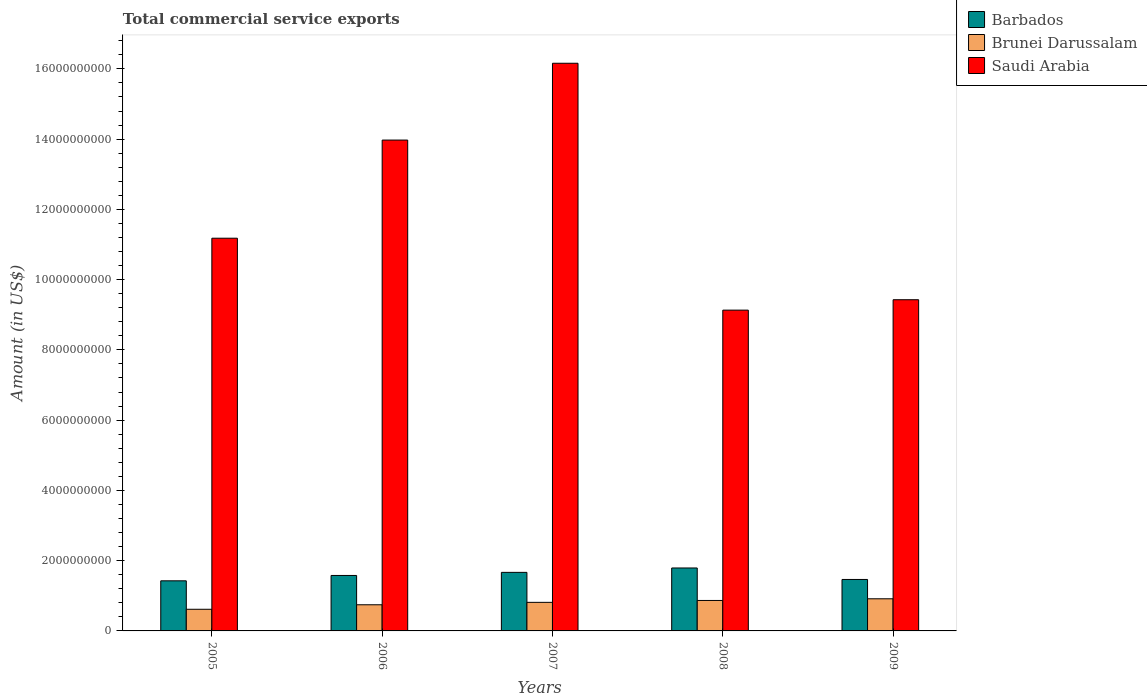How many different coloured bars are there?
Offer a terse response. 3. Are the number of bars per tick equal to the number of legend labels?
Give a very brief answer. Yes. How many bars are there on the 1st tick from the left?
Make the answer very short. 3. How many bars are there on the 2nd tick from the right?
Your answer should be compact. 3. What is the total commercial service exports in Saudi Arabia in 2006?
Ensure brevity in your answer.  1.40e+1. Across all years, what is the maximum total commercial service exports in Saudi Arabia?
Provide a short and direct response. 1.62e+1. Across all years, what is the minimum total commercial service exports in Barbados?
Offer a terse response. 1.43e+09. In which year was the total commercial service exports in Brunei Darussalam minimum?
Provide a succinct answer. 2005. What is the total total commercial service exports in Brunei Darussalam in the graph?
Provide a succinct answer. 3.96e+09. What is the difference between the total commercial service exports in Saudi Arabia in 2005 and that in 2008?
Ensure brevity in your answer.  2.05e+09. What is the difference between the total commercial service exports in Brunei Darussalam in 2007 and the total commercial service exports in Saudi Arabia in 2005?
Your answer should be compact. -1.04e+1. What is the average total commercial service exports in Barbados per year?
Ensure brevity in your answer.  1.59e+09. In the year 2008, what is the difference between the total commercial service exports in Brunei Darussalam and total commercial service exports in Barbados?
Provide a succinct answer. -9.25e+08. In how many years, is the total commercial service exports in Barbados greater than 800000000 US$?
Provide a succinct answer. 5. What is the ratio of the total commercial service exports in Brunei Darussalam in 2006 to that in 2009?
Your answer should be very brief. 0.81. Is the total commercial service exports in Barbados in 2006 less than that in 2008?
Make the answer very short. Yes. Is the difference between the total commercial service exports in Brunei Darussalam in 2005 and 2009 greater than the difference between the total commercial service exports in Barbados in 2005 and 2009?
Offer a terse response. No. What is the difference between the highest and the second highest total commercial service exports in Brunei Darussalam?
Give a very brief answer. 4.77e+07. What is the difference between the highest and the lowest total commercial service exports in Saudi Arabia?
Offer a terse response. 7.03e+09. In how many years, is the total commercial service exports in Saudi Arabia greater than the average total commercial service exports in Saudi Arabia taken over all years?
Provide a short and direct response. 2. What does the 2nd bar from the left in 2006 represents?
Give a very brief answer. Brunei Darussalam. What does the 2nd bar from the right in 2008 represents?
Offer a very short reply. Brunei Darussalam. Is it the case that in every year, the sum of the total commercial service exports in Barbados and total commercial service exports in Saudi Arabia is greater than the total commercial service exports in Brunei Darussalam?
Make the answer very short. Yes. Are all the bars in the graph horizontal?
Your response must be concise. No. What is the difference between two consecutive major ticks on the Y-axis?
Your answer should be compact. 2.00e+09. Does the graph contain any zero values?
Offer a very short reply. No. Where does the legend appear in the graph?
Your answer should be very brief. Top right. What is the title of the graph?
Offer a terse response. Total commercial service exports. Does "Egypt, Arab Rep." appear as one of the legend labels in the graph?
Provide a succinct answer. No. What is the label or title of the X-axis?
Ensure brevity in your answer.  Years. What is the Amount (in US$) of Barbados in 2005?
Make the answer very short. 1.43e+09. What is the Amount (in US$) in Brunei Darussalam in 2005?
Ensure brevity in your answer.  6.16e+08. What is the Amount (in US$) in Saudi Arabia in 2005?
Provide a short and direct response. 1.12e+1. What is the Amount (in US$) of Barbados in 2006?
Offer a terse response. 1.58e+09. What is the Amount (in US$) of Brunei Darussalam in 2006?
Provide a short and direct response. 7.45e+08. What is the Amount (in US$) in Saudi Arabia in 2006?
Provide a succinct answer. 1.40e+1. What is the Amount (in US$) of Barbados in 2007?
Your response must be concise. 1.67e+09. What is the Amount (in US$) of Brunei Darussalam in 2007?
Offer a very short reply. 8.13e+08. What is the Amount (in US$) in Saudi Arabia in 2007?
Offer a terse response. 1.62e+1. What is the Amount (in US$) in Barbados in 2008?
Give a very brief answer. 1.79e+09. What is the Amount (in US$) of Brunei Darussalam in 2008?
Provide a short and direct response. 8.67e+08. What is the Amount (in US$) in Saudi Arabia in 2008?
Offer a terse response. 9.13e+09. What is the Amount (in US$) of Barbados in 2009?
Your response must be concise. 1.46e+09. What is the Amount (in US$) in Brunei Darussalam in 2009?
Your answer should be very brief. 9.15e+08. What is the Amount (in US$) in Saudi Arabia in 2009?
Provide a succinct answer. 9.43e+09. Across all years, what is the maximum Amount (in US$) in Barbados?
Make the answer very short. 1.79e+09. Across all years, what is the maximum Amount (in US$) of Brunei Darussalam?
Provide a short and direct response. 9.15e+08. Across all years, what is the maximum Amount (in US$) in Saudi Arabia?
Provide a succinct answer. 1.62e+1. Across all years, what is the minimum Amount (in US$) of Barbados?
Give a very brief answer. 1.43e+09. Across all years, what is the minimum Amount (in US$) in Brunei Darussalam?
Your answer should be compact. 6.16e+08. Across all years, what is the minimum Amount (in US$) of Saudi Arabia?
Keep it short and to the point. 9.13e+09. What is the total Amount (in US$) in Barbados in the graph?
Ensure brevity in your answer.  7.93e+09. What is the total Amount (in US$) of Brunei Darussalam in the graph?
Your answer should be compact. 3.96e+09. What is the total Amount (in US$) of Saudi Arabia in the graph?
Make the answer very short. 5.99e+1. What is the difference between the Amount (in US$) in Barbados in 2005 and that in 2006?
Give a very brief answer. -1.53e+08. What is the difference between the Amount (in US$) in Brunei Darussalam in 2005 and that in 2006?
Offer a very short reply. -1.28e+08. What is the difference between the Amount (in US$) of Saudi Arabia in 2005 and that in 2006?
Make the answer very short. -2.79e+09. What is the difference between the Amount (in US$) in Barbados in 2005 and that in 2007?
Offer a terse response. -2.41e+08. What is the difference between the Amount (in US$) in Brunei Darussalam in 2005 and that in 2007?
Your answer should be very brief. -1.97e+08. What is the difference between the Amount (in US$) of Saudi Arabia in 2005 and that in 2007?
Keep it short and to the point. -4.98e+09. What is the difference between the Amount (in US$) in Barbados in 2005 and that in 2008?
Your response must be concise. -3.66e+08. What is the difference between the Amount (in US$) in Brunei Darussalam in 2005 and that in 2008?
Offer a terse response. -2.51e+08. What is the difference between the Amount (in US$) of Saudi Arabia in 2005 and that in 2008?
Keep it short and to the point. 2.05e+09. What is the difference between the Amount (in US$) in Barbados in 2005 and that in 2009?
Offer a terse response. -3.87e+07. What is the difference between the Amount (in US$) in Brunei Darussalam in 2005 and that in 2009?
Give a very brief answer. -2.99e+08. What is the difference between the Amount (in US$) in Saudi Arabia in 2005 and that in 2009?
Provide a short and direct response. 1.75e+09. What is the difference between the Amount (in US$) in Barbados in 2006 and that in 2007?
Offer a terse response. -8.84e+07. What is the difference between the Amount (in US$) of Brunei Darussalam in 2006 and that in 2007?
Give a very brief answer. -6.88e+07. What is the difference between the Amount (in US$) of Saudi Arabia in 2006 and that in 2007?
Your response must be concise. -2.19e+09. What is the difference between the Amount (in US$) in Barbados in 2006 and that in 2008?
Keep it short and to the point. -2.13e+08. What is the difference between the Amount (in US$) of Brunei Darussalam in 2006 and that in 2008?
Make the answer very short. -1.23e+08. What is the difference between the Amount (in US$) in Saudi Arabia in 2006 and that in 2008?
Keep it short and to the point. 4.84e+09. What is the difference between the Amount (in US$) in Barbados in 2006 and that in 2009?
Make the answer very short. 1.14e+08. What is the difference between the Amount (in US$) in Brunei Darussalam in 2006 and that in 2009?
Your answer should be very brief. -1.70e+08. What is the difference between the Amount (in US$) of Saudi Arabia in 2006 and that in 2009?
Your answer should be compact. 4.55e+09. What is the difference between the Amount (in US$) in Barbados in 2007 and that in 2008?
Your response must be concise. -1.25e+08. What is the difference between the Amount (in US$) in Brunei Darussalam in 2007 and that in 2008?
Provide a succinct answer. -5.39e+07. What is the difference between the Amount (in US$) in Saudi Arabia in 2007 and that in 2008?
Ensure brevity in your answer.  7.03e+09. What is the difference between the Amount (in US$) of Barbados in 2007 and that in 2009?
Give a very brief answer. 2.02e+08. What is the difference between the Amount (in US$) of Brunei Darussalam in 2007 and that in 2009?
Make the answer very short. -1.02e+08. What is the difference between the Amount (in US$) in Saudi Arabia in 2007 and that in 2009?
Keep it short and to the point. 6.73e+09. What is the difference between the Amount (in US$) in Barbados in 2008 and that in 2009?
Give a very brief answer. 3.27e+08. What is the difference between the Amount (in US$) of Brunei Darussalam in 2008 and that in 2009?
Provide a short and direct response. -4.77e+07. What is the difference between the Amount (in US$) in Saudi Arabia in 2008 and that in 2009?
Make the answer very short. -2.96e+08. What is the difference between the Amount (in US$) in Barbados in 2005 and the Amount (in US$) in Brunei Darussalam in 2006?
Make the answer very short. 6.82e+08. What is the difference between the Amount (in US$) of Barbados in 2005 and the Amount (in US$) of Saudi Arabia in 2006?
Offer a very short reply. -1.25e+1. What is the difference between the Amount (in US$) of Brunei Darussalam in 2005 and the Amount (in US$) of Saudi Arabia in 2006?
Ensure brevity in your answer.  -1.34e+1. What is the difference between the Amount (in US$) in Barbados in 2005 and the Amount (in US$) in Brunei Darussalam in 2007?
Your answer should be compact. 6.13e+08. What is the difference between the Amount (in US$) in Barbados in 2005 and the Amount (in US$) in Saudi Arabia in 2007?
Offer a very short reply. -1.47e+1. What is the difference between the Amount (in US$) of Brunei Darussalam in 2005 and the Amount (in US$) of Saudi Arabia in 2007?
Offer a terse response. -1.55e+1. What is the difference between the Amount (in US$) of Barbados in 2005 and the Amount (in US$) of Brunei Darussalam in 2008?
Give a very brief answer. 5.59e+08. What is the difference between the Amount (in US$) of Barbados in 2005 and the Amount (in US$) of Saudi Arabia in 2008?
Your response must be concise. -7.71e+09. What is the difference between the Amount (in US$) in Brunei Darussalam in 2005 and the Amount (in US$) in Saudi Arabia in 2008?
Your answer should be compact. -8.52e+09. What is the difference between the Amount (in US$) of Barbados in 2005 and the Amount (in US$) of Brunei Darussalam in 2009?
Your response must be concise. 5.11e+08. What is the difference between the Amount (in US$) in Barbados in 2005 and the Amount (in US$) in Saudi Arabia in 2009?
Provide a short and direct response. -8.00e+09. What is the difference between the Amount (in US$) in Brunei Darussalam in 2005 and the Amount (in US$) in Saudi Arabia in 2009?
Your answer should be compact. -8.81e+09. What is the difference between the Amount (in US$) of Barbados in 2006 and the Amount (in US$) of Brunei Darussalam in 2007?
Offer a very short reply. 7.65e+08. What is the difference between the Amount (in US$) in Barbados in 2006 and the Amount (in US$) in Saudi Arabia in 2007?
Your answer should be very brief. -1.46e+1. What is the difference between the Amount (in US$) in Brunei Darussalam in 2006 and the Amount (in US$) in Saudi Arabia in 2007?
Your answer should be very brief. -1.54e+1. What is the difference between the Amount (in US$) of Barbados in 2006 and the Amount (in US$) of Brunei Darussalam in 2008?
Offer a very short reply. 7.11e+08. What is the difference between the Amount (in US$) in Barbados in 2006 and the Amount (in US$) in Saudi Arabia in 2008?
Ensure brevity in your answer.  -7.55e+09. What is the difference between the Amount (in US$) in Brunei Darussalam in 2006 and the Amount (in US$) in Saudi Arabia in 2008?
Keep it short and to the point. -8.39e+09. What is the difference between the Amount (in US$) of Barbados in 2006 and the Amount (in US$) of Brunei Darussalam in 2009?
Provide a succinct answer. 6.64e+08. What is the difference between the Amount (in US$) of Barbados in 2006 and the Amount (in US$) of Saudi Arabia in 2009?
Offer a very short reply. -7.85e+09. What is the difference between the Amount (in US$) of Brunei Darussalam in 2006 and the Amount (in US$) of Saudi Arabia in 2009?
Your answer should be very brief. -8.68e+09. What is the difference between the Amount (in US$) in Barbados in 2007 and the Amount (in US$) in Brunei Darussalam in 2008?
Offer a terse response. 8.00e+08. What is the difference between the Amount (in US$) of Barbados in 2007 and the Amount (in US$) of Saudi Arabia in 2008?
Offer a very short reply. -7.46e+09. What is the difference between the Amount (in US$) in Brunei Darussalam in 2007 and the Amount (in US$) in Saudi Arabia in 2008?
Your answer should be very brief. -8.32e+09. What is the difference between the Amount (in US$) of Barbados in 2007 and the Amount (in US$) of Brunei Darussalam in 2009?
Provide a short and direct response. 7.52e+08. What is the difference between the Amount (in US$) in Barbados in 2007 and the Amount (in US$) in Saudi Arabia in 2009?
Give a very brief answer. -7.76e+09. What is the difference between the Amount (in US$) in Brunei Darussalam in 2007 and the Amount (in US$) in Saudi Arabia in 2009?
Make the answer very short. -8.61e+09. What is the difference between the Amount (in US$) of Barbados in 2008 and the Amount (in US$) of Brunei Darussalam in 2009?
Your answer should be very brief. 8.77e+08. What is the difference between the Amount (in US$) of Barbados in 2008 and the Amount (in US$) of Saudi Arabia in 2009?
Your answer should be very brief. -7.64e+09. What is the difference between the Amount (in US$) in Brunei Darussalam in 2008 and the Amount (in US$) in Saudi Arabia in 2009?
Make the answer very short. -8.56e+09. What is the average Amount (in US$) in Barbados per year?
Your response must be concise. 1.59e+09. What is the average Amount (in US$) of Brunei Darussalam per year?
Your response must be concise. 7.91e+08. What is the average Amount (in US$) of Saudi Arabia per year?
Keep it short and to the point. 1.20e+1. In the year 2005, what is the difference between the Amount (in US$) in Barbados and Amount (in US$) in Brunei Darussalam?
Make the answer very short. 8.10e+08. In the year 2005, what is the difference between the Amount (in US$) in Barbados and Amount (in US$) in Saudi Arabia?
Provide a succinct answer. -9.75e+09. In the year 2005, what is the difference between the Amount (in US$) in Brunei Darussalam and Amount (in US$) in Saudi Arabia?
Provide a short and direct response. -1.06e+1. In the year 2006, what is the difference between the Amount (in US$) in Barbados and Amount (in US$) in Brunei Darussalam?
Provide a succinct answer. 8.34e+08. In the year 2006, what is the difference between the Amount (in US$) in Barbados and Amount (in US$) in Saudi Arabia?
Your answer should be compact. -1.24e+1. In the year 2006, what is the difference between the Amount (in US$) in Brunei Darussalam and Amount (in US$) in Saudi Arabia?
Ensure brevity in your answer.  -1.32e+1. In the year 2007, what is the difference between the Amount (in US$) in Barbados and Amount (in US$) in Brunei Darussalam?
Ensure brevity in your answer.  8.54e+08. In the year 2007, what is the difference between the Amount (in US$) of Barbados and Amount (in US$) of Saudi Arabia?
Provide a short and direct response. -1.45e+1. In the year 2007, what is the difference between the Amount (in US$) in Brunei Darussalam and Amount (in US$) in Saudi Arabia?
Offer a very short reply. -1.53e+1. In the year 2008, what is the difference between the Amount (in US$) of Barbados and Amount (in US$) of Brunei Darussalam?
Your answer should be compact. 9.25e+08. In the year 2008, what is the difference between the Amount (in US$) in Barbados and Amount (in US$) in Saudi Arabia?
Your response must be concise. -7.34e+09. In the year 2008, what is the difference between the Amount (in US$) of Brunei Darussalam and Amount (in US$) of Saudi Arabia?
Keep it short and to the point. -8.26e+09. In the year 2009, what is the difference between the Amount (in US$) in Barbados and Amount (in US$) in Brunei Darussalam?
Your answer should be compact. 5.50e+08. In the year 2009, what is the difference between the Amount (in US$) of Barbados and Amount (in US$) of Saudi Arabia?
Ensure brevity in your answer.  -7.96e+09. In the year 2009, what is the difference between the Amount (in US$) of Brunei Darussalam and Amount (in US$) of Saudi Arabia?
Keep it short and to the point. -8.51e+09. What is the ratio of the Amount (in US$) in Barbados in 2005 to that in 2006?
Offer a terse response. 0.9. What is the ratio of the Amount (in US$) of Brunei Darussalam in 2005 to that in 2006?
Make the answer very short. 0.83. What is the ratio of the Amount (in US$) in Saudi Arabia in 2005 to that in 2006?
Your response must be concise. 0.8. What is the ratio of the Amount (in US$) in Barbados in 2005 to that in 2007?
Your response must be concise. 0.86. What is the ratio of the Amount (in US$) of Brunei Darussalam in 2005 to that in 2007?
Provide a short and direct response. 0.76. What is the ratio of the Amount (in US$) in Saudi Arabia in 2005 to that in 2007?
Your response must be concise. 0.69. What is the ratio of the Amount (in US$) in Barbados in 2005 to that in 2008?
Make the answer very short. 0.8. What is the ratio of the Amount (in US$) in Brunei Darussalam in 2005 to that in 2008?
Offer a terse response. 0.71. What is the ratio of the Amount (in US$) of Saudi Arabia in 2005 to that in 2008?
Keep it short and to the point. 1.22. What is the ratio of the Amount (in US$) of Barbados in 2005 to that in 2009?
Your response must be concise. 0.97. What is the ratio of the Amount (in US$) in Brunei Darussalam in 2005 to that in 2009?
Make the answer very short. 0.67. What is the ratio of the Amount (in US$) in Saudi Arabia in 2005 to that in 2009?
Your answer should be compact. 1.19. What is the ratio of the Amount (in US$) in Barbados in 2006 to that in 2007?
Keep it short and to the point. 0.95. What is the ratio of the Amount (in US$) in Brunei Darussalam in 2006 to that in 2007?
Ensure brevity in your answer.  0.92. What is the ratio of the Amount (in US$) of Saudi Arabia in 2006 to that in 2007?
Provide a short and direct response. 0.86. What is the ratio of the Amount (in US$) of Barbados in 2006 to that in 2008?
Ensure brevity in your answer.  0.88. What is the ratio of the Amount (in US$) in Brunei Darussalam in 2006 to that in 2008?
Give a very brief answer. 0.86. What is the ratio of the Amount (in US$) of Saudi Arabia in 2006 to that in 2008?
Offer a terse response. 1.53. What is the ratio of the Amount (in US$) in Barbados in 2006 to that in 2009?
Offer a terse response. 1.08. What is the ratio of the Amount (in US$) in Brunei Darussalam in 2006 to that in 2009?
Provide a succinct answer. 0.81. What is the ratio of the Amount (in US$) of Saudi Arabia in 2006 to that in 2009?
Ensure brevity in your answer.  1.48. What is the ratio of the Amount (in US$) in Barbados in 2007 to that in 2008?
Offer a very short reply. 0.93. What is the ratio of the Amount (in US$) in Brunei Darussalam in 2007 to that in 2008?
Provide a succinct answer. 0.94. What is the ratio of the Amount (in US$) of Saudi Arabia in 2007 to that in 2008?
Give a very brief answer. 1.77. What is the ratio of the Amount (in US$) in Barbados in 2007 to that in 2009?
Your response must be concise. 1.14. What is the ratio of the Amount (in US$) in Brunei Darussalam in 2007 to that in 2009?
Provide a short and direct response. 0.89. What is the ratio of the Amount (in US$) of Saudi Arabia in 2007 to that in 2009?
Make the answer very short. 1.71. What is the ratio of the Amount (in US$) in Barbados in 2008 to that in 2009?
Keep it short and to the point. 1.22. What is the ratio of the Amount (in US$) of Brunei Darussalam in 2008 to that in 2009?
Provide a short and direct response. 0.95. What is the ratio of the Amount (in US$) in Saudi Arabia in 2008 to that in 2009?
Your response must be concise. 0.97. What is the difference between the highest and the second highest Amount (in US$) of Barbados?
Ensure brevity in your answer.  1.25e+08. What is the difference between the highest and the second highest Amount (in US$) of Brunei Darussalam?
Keep it short and to the point. 4.77e+07. What is the difference between the highest and the second highest Amount (in US$) in Saudi Arabia?
Give a very brief answer. 2.19e+09. What is the difference between the highest and the lowest Amount (in US$) of Barbados?
Your answer should be very brief. 3.66e+08. What is the difference between the highest and the lowest Amount (in US$) in Brunei Darussalam?
Offer a terse response. 2.99e+08. What is the difference between the highest and the lowest Amount (in US$) in Saudi Arabia?
Provide a succinct answer. 7.03e+09. 